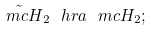<formula> <loc_0><loc_0><loc_500><loc_500>\tilde { \ m c H } _ { 2 } \ h r a \ m c H _ { 2 } ;</formula> 